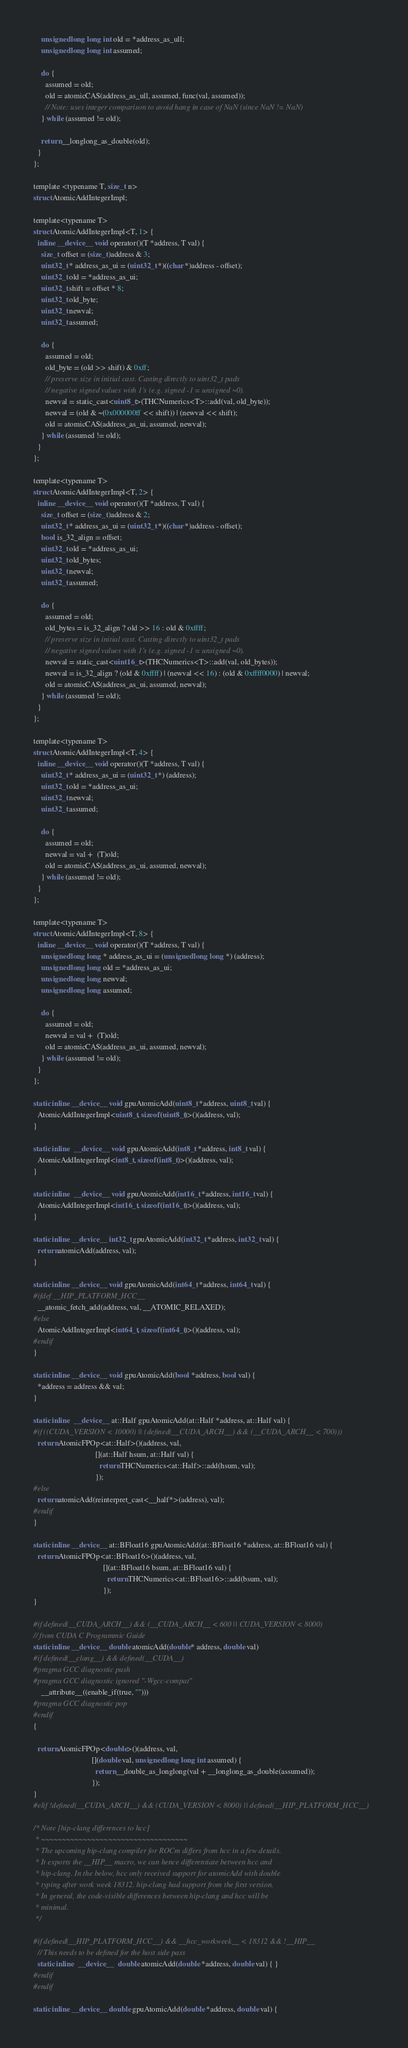Convert code to text. <code><loc_0><loc_0><loc_500><loc_500><_Cuda_>    unsigned long long int old = *address_as_ull;
    unsigned long long int assumed;

    do {
      assumed = old;
      old = atomicCAS(address_as_ull, assumed, func(val, assumed));
      // Note: uses integer comparison to avoid hang in case of NaN (since NaN != NaN)
    } while (assumed != old);

    return __longlong_as_double(old);
  }
};

template <typename T, size_t n>
struct AtomicAddIntegerImpl;

template<typename T>
struct AtomicAddIntegerImpl<T, 1> {
  inline __device__ void operator()(T *address, T val) {
    size_t offset = (size_t)address & 3;
    uint32_t * address_as_ui = (uint32_t *)((char *)address - offset);
    uint32_t old = *address_as_ui;
    uint32_t shift = offset * 8;
    uint32_t old_byte;
    uint32_t newval;
    uint32_t assumed;

    do {
      assumed = old;
      old_byte = (old >> shift) & 0xff;
      // preserve size in initial cast. Casting directly to uint32_t pads
      // negative signed values with 1's (e.g. signed -1 = unsigned ~0).
      newval = static_cast<uint8_t>(THCNumerics<T>::add(val, old_byte));
      newval = (old & ~(0x000000ff << shift)) | (newval << shift);
      old = atomicCAS(address_as_ui, assumed, newval);
    } while (assumed != old);
  }
};

template<typename T>
struct AtomicAddIntegerImpl<T, 2> {
  inline __device__ void operator()(T *address, T val) {
    size_t offset = (size_t)address & 2;
    uint32_t * address_as_ui = (uint32_t *)((char *)address - offset);
    bool is_32_align = offset;
    uint32_t old = *address_as_ui;
    uint32_t old_bytes;
    uint32_t newval;
    uint32_t assumed;

    do {
      assumed = old;
      old_bytes = is_32_align ? old >> 16 : old & 0xffff;
      // preserve size in initial cast. Casting directly to uint32_t pads
      // negative signed values with 1's (e.g. signed -1 = unsigned ~0).
      newval = static_cast<uint16_t>(THCNumerics<T>::add(val, old_bytes));
      newval = is_32_align ? (old & 0xffff) | (newval << 16) : (old & 0xffff0000) | newval;
      old = atomicCAS(address_as_ui, assumed, newval);
    } while (assumed != old);
  }
};

template<typename T>
struct AtomicAddIntegerImpl<T, 4> {
  inline __device__ void operator()(T *address, T val) {
    uint32_t * address_as_ui = (uint32_t *) (address);
    uint32_t old = *address_as_ui;
    uint32_t newval;
    uint32_t assumed;

    do {
      assumed = old;
      newval = val +  (T)old;
      old = atomicCAS(address_as_ui, assumed, newval);
    } while (assumed != old);
  }
};

template<typename T>
struct AtomicAddIntegerImpl<T, 8> {
  inline __device__ void operator()(T *address, T val) {
    unsigned long long * address_as_ui = (unsigned long long *) (address);
    unsigned long long old = *address_as_ui;
    unsigned long long newval;
    unsigned long long assumed;

    do {
      assumed = old;
      newval = val +  (T)old;
      old = atomicCAS(address_as_ui, assumed, newval);
    } while (assumed != old);
  }
};

static inline __device__ void gpuAtomicAdd(uint8_t *address, uint8_t val) {
  AtomicAddIntegerImpl<uint8_t, sizeof(uint8_t)>()(address, val);
}

static inline  __device__ void gpuAtomicAdd(int8_t *address, int8_t val) {
  AtomicAddIntegerImpl<int8_t, sizeof(int8_t)>()(address, val);
}

static inline  __device__ void gpuAtomicAdd(int16_t *address, int16_t val) {
  AtomicAddIntegerImpl<int16_t, sizeof(int16_t)>()(address, val);
}

static inline __device__ int32_t gpuAtomicAdd(int32_t *address, int32_t val) {
  return atomicAdd(address, val);
}

static inline __device__ void gpuAtomicAdd(int64_t *address, int64_t val) {
#ifdef __HIP_PLATFORM_HCC__
  __atomic_fetch_add(address, val, __ATOMIC_RELAXED);
#else
  AtomicAddIntegerImpl<int64_t, sizeof(int64_t)>()(address, val);
#endif
}

static inline __device__ void gpuAtomicAdd(bool *address, bool val) {
  *address = address && val;
}

static inline  __device__ at::Half gpuAtomicAdd(at::Half *address, at::Half val) {
#if ((CUDA_VERSION < 10000) || (defined(__CUDA_ARCH__) && (__CUDA_ARCH__ < 700)))
  return AtomicFPOp<at::Half>()(address, val,
                                [](at::Half hsum, at::Half val) {
                                  return THCNumerics<at::Half>::add(hsum, val);
                                });
#else
  return atomicAdd(reinterpret_cast<__half*>(address), val);
#endif
}

static inline __device__ at::BFloat16 gpuAtomicAdd(at::BFloat16 *address, at::BFloat16 val) {
  return AtomicFPOp<at::BFloat16>()(address, val,
                                    [](at::BFloat16 bsum, at::BFloat16 val) {
                                      return THCNumerics<at::BFloat16>::add(bsum, val);
                                    });
}

#if defined(__CUDA_ARCH__) && (__CUDA_ARCH__ < 600 || CUDA_VERSION < 8000)
// from CUDA C Programmic Guide
static inline __device__ double atomicAdd(double* address, double val)
#if defined(__clang__) && defined(__CUDA__)
#pragma GCC diagnostic push
#pragma GCC diagnostic ignored "-Wgcc-compat"
    __attribute__((enable_if(true, "")))
#pragma GCC diagnostic pop
#endif
{

  return AtomicFPOp<double>()(address, val,
                              [](double val, unsigned long long int assumed) {
                                return __double_as_longlong(val + __longlong_as_double(assumed));
                              });
}
#elif !defined(__CUDA_ARCH__) && (CUDA_VERSION < 8000) || defined(__HIP_PLATFORM_HCC__)

/* Note [hip-clang differences to hcc]
 * ~~~~~~~~~~~~~~~~~~~~~~~~~~~~~~~~~~~
 * The upcoming hip-clang compiler for ROCm differs from hcc in a few details.
 * It exports the __HIP__ macro, we can hence differentiate between hcc and
 * hip-clang. In the below, hcc only received support for atomicAdd with double
 * typing after work week 18312. hip-clang had support from the first version.
 * In general, the code-visible differences between hip-clang and hcc will be
 * minimal.
 */

#if defined(__HIP_PLATFORM_HCC__) && __hcc_workweek__ < 18312 && !__HIP__
  // This needs to be defined for the host side pass
  static inline  __device__  double atomicAdd(double *address, double val) { }
#endif
#endif

static inline __device__ double gpuAtomicAdd(double *address, double val) {</code> 